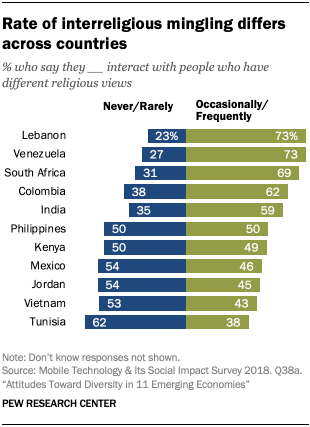Give some essential details in this illustration. The difference between blue and green graphics is greatest in Lebanon. The color of the graph in Mexico is blue, and its value is 54. 